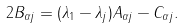<formula> <loc_0><loc_0><loc_500><loc_500>2 B _ { \alpha j } = ( \lambda _ { 1 } - \lambda _ { j } ) A _ { \alpha j } - C _ { \alpha j } .</formula> 